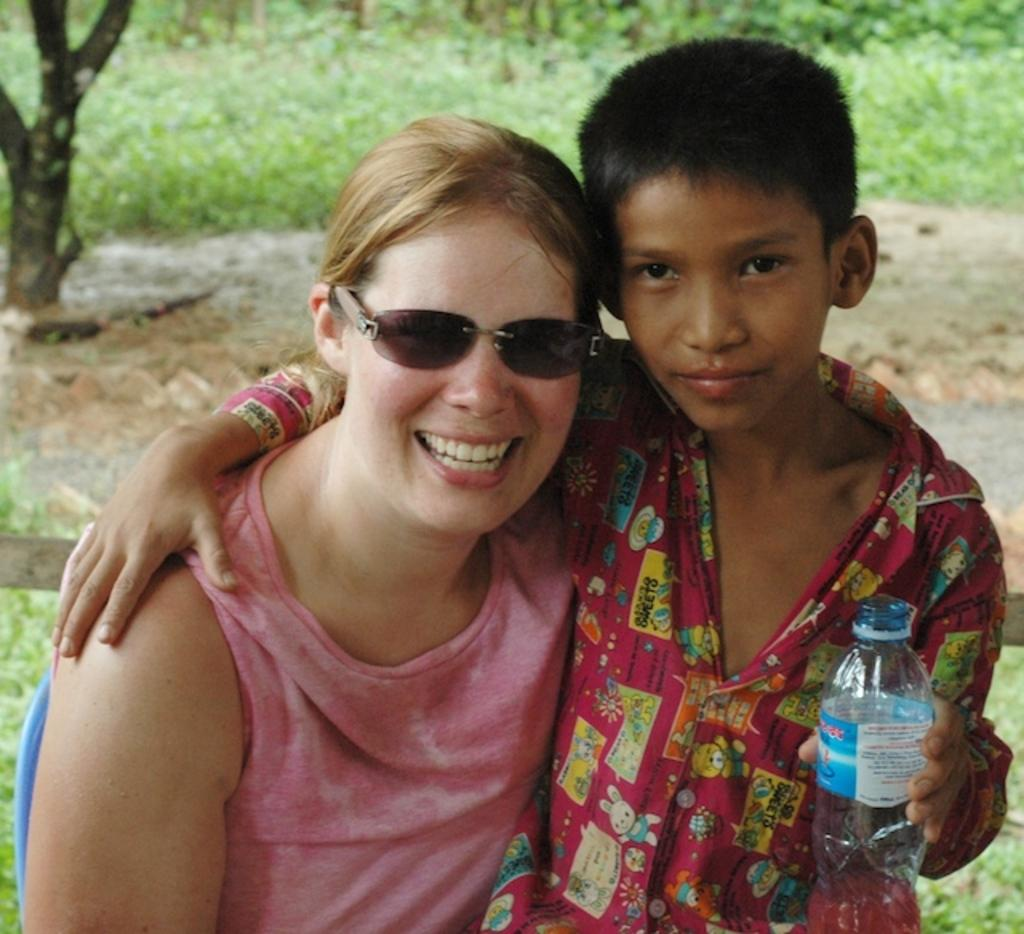What is the main object in the image? There is a tree stem in the image. What type of vegetation is present in the image? There is grass in the image. How many people are visible in the image? There are two people in the front of the image. What is the gender of one of the people? One of the people is a boy. What is the boy holding in the image? The boy is holding a bottle. What type of plastic is covering the badge on the boy's chin? There is no plastic, badge, or chin mentioned in the image. The boy is holding a bottle, but there is no indication of a badge or plastic on his chin. 